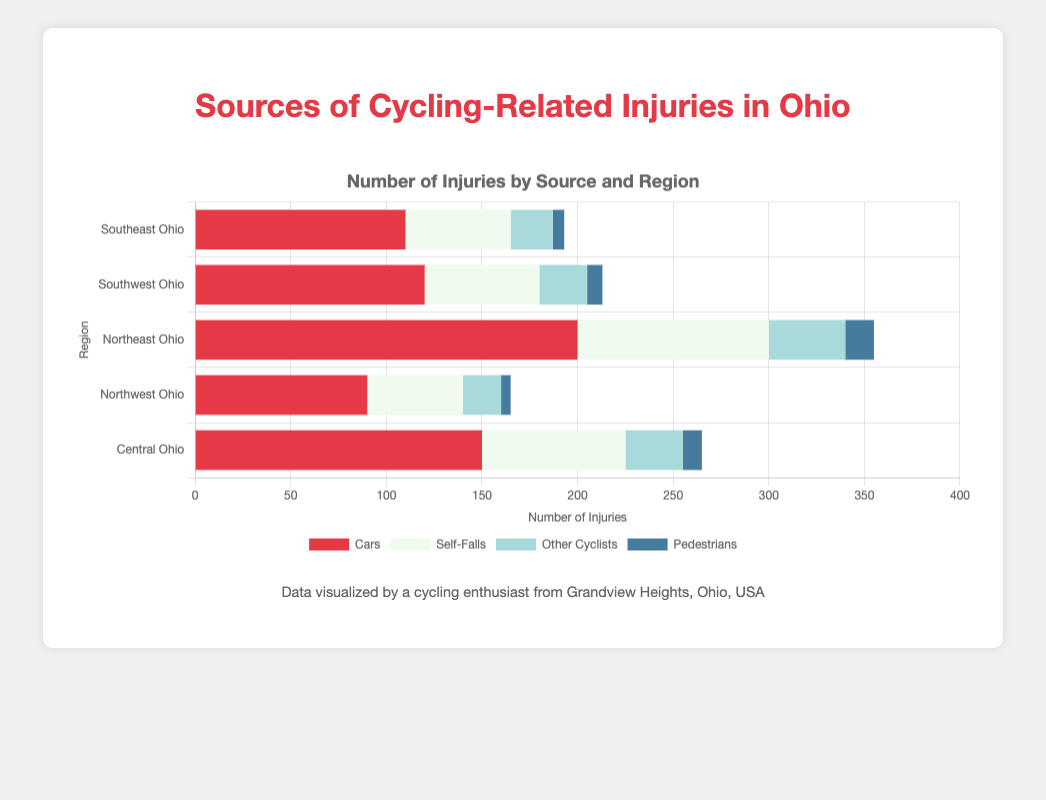Which region has the highest number of injuries from cars? Central Ohio has 150 injuries from cars, Northwest has 90, Northeast has 200, Southwest has 120, and Southeast has 110. The highest number is in Northeast Ohio.
Answer: Northeast Ohio Sum the total number of injuries from self-falls for all regions. Adding the self-falls from all regions: 75 (Central) + 50 (Northwest) + 100 (Northeast) + 60 (Southwest) + 55 (Southeast) = 340.
Answer: 340 Which source of injuries has the least number in Southeast Ohio? According to the chart, Pedestrians have 6 injuries, which is lower than Cars (110), Self-Falls (55), and Other Cyclists (22).
Answer: Pedestrians Compare the number of injuries caused by other cyclists in Central Ohio and Northwest Ohio. Which region has more? Central Ohio has 30 injuries from other cyclists, while Northwest Ohio has 20. Central Ohio has more.
Answer: Central Ohio What's the average number of injuries caused by pedestrians across all regions? Adding the pedestrian injuries from all regions: 10 (Central) + 5 (Northwest) + 15 (Northeast) + 8 (Southwest) + 6 (Southeast) = 44. The average is 44 / 5 = 8.8.
Answer: 8.8 If you combine injuries from cars and self-falls in Northeast Ohio, how many injuries are there in total? Northeast Ohio has 200 injuries from cars and 100 from self-falls. Adding them together: 200 + 100 = 300.
Answer: 300 Which source of injuries has the second-highest number in Southwest Ohio? In Southwest Ohio, Cars have 120, Self-Falls have 60, Other Cyclists have 25, and Pedestrians have 8. The second-highest is Self-Falls with 60.
Answer: Self-Falls Is the number of injuries from other cyclists in Northeast Ohio greater than the number of injuries from pedestrians in Central Ohio? Northeast Ohio has 40 injuries from other cyclists, while Central Ohio has 10 from pedestrians. 40 > 10.
Answer: Yes In which region is the sum of injuries from cars and other cyclists equal to the number of self-falls in the same region? Adding injuries from cars and other cyclists in Central Ohio: 150 (Cars) + 30 (Other Cyclists) = 180. In Northwest Ohio: 90 (Cars) + 20 (Other Cyclists) = 110. In Northeast Ohio: 200 (Cars) + 40 (Other Cyclists) = 240. In Southwest Ohio: 120 (Cars) + 25 (Other Cyclists) = 145. In Southeast Ohio: 110 (Cars) + 22 (Other Cyclists) = 132. Only in Central Ohio, sum of 180 is equal to 180 self-falls (75), none match.
Answer: None Which region has the smallest total number of cycling-related injuries? Calculating the total injuries in each region: Central Ohio (150+75+30+10)=265, Northwest Ohio (90+50+20+5)=165, Northeast Ohio (200+100+40+15)=355, Southwest Ohio (120+60+25+8)=213, Southeast Ohio (110+55+22+6)=193. The smallest total is in Northwest Ohio.
Answer: Northwest Ohio 